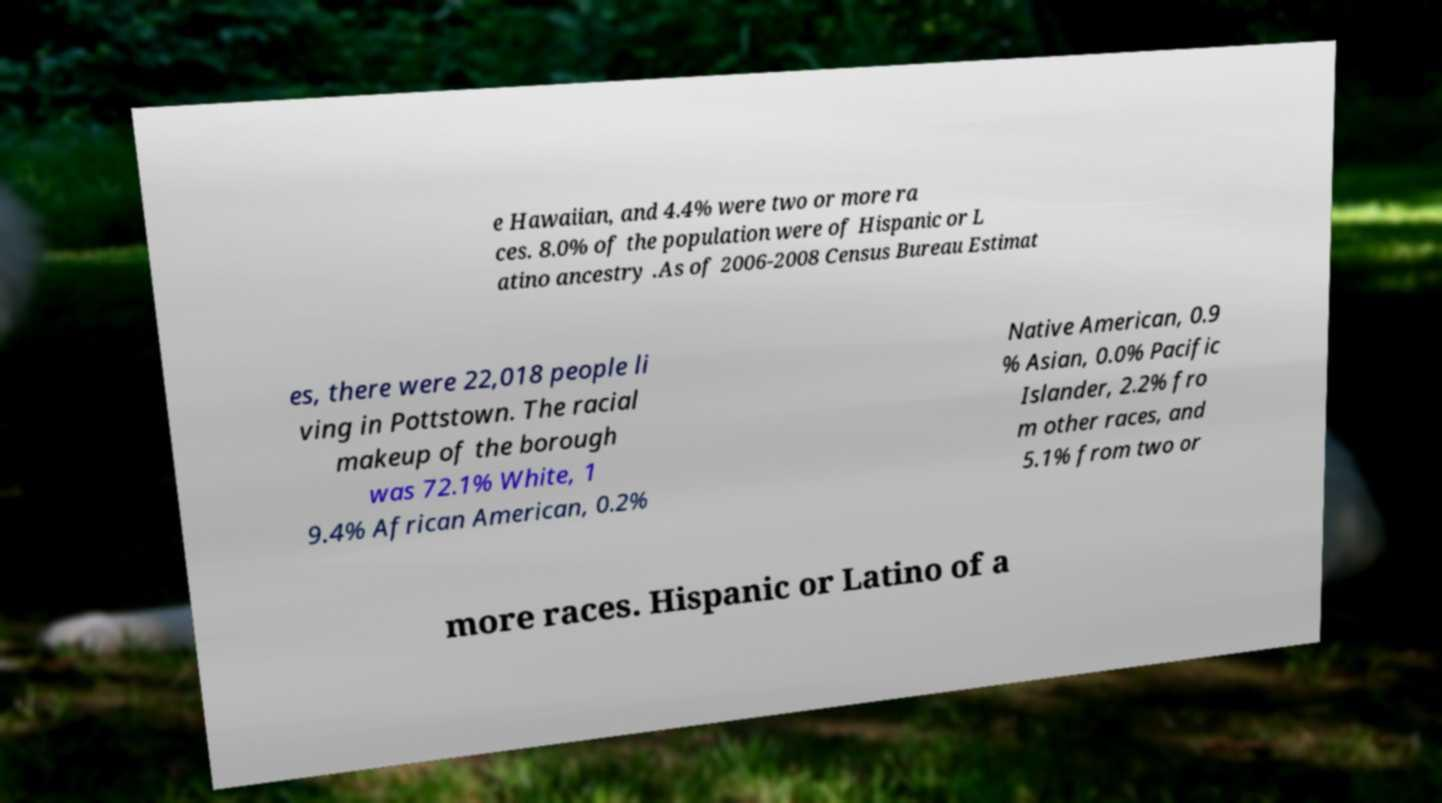I need the written content from this picture converted into text. Can you do that? e Hawaiian, and 4.4% were two or more ra ces. 8.0% of the population were of Hispanic or L atino ancestry .As of 2006-2008 Census Bureau Estimat es, there were 22,018 people li ving in Pottstown. The racial makeup of the borough was 72.1% White, 1 9.4% African American, 0.2% Native American, 0.9 % Asian, 0.0% Pacific Islander, 2.2% fro m other races, and 5.1% from two or more races. Hispanic or Latino of a 